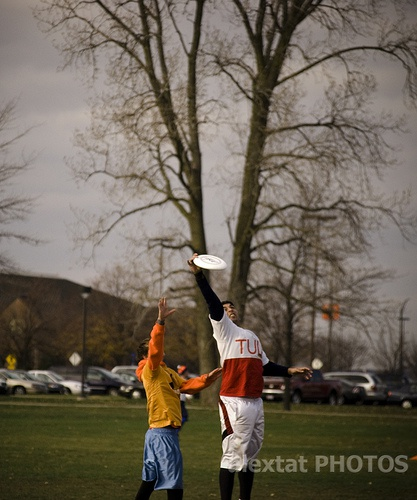Describe the objects in this image and their specific colors. I can see people in gray, black, darkgray, maroon, and lightgray tones, people in gray, black, olive, and maroon tones, car in gray, black, and maroon tones, car in gray and black tones, and car in gray, black, and darkgray tones in this image. 